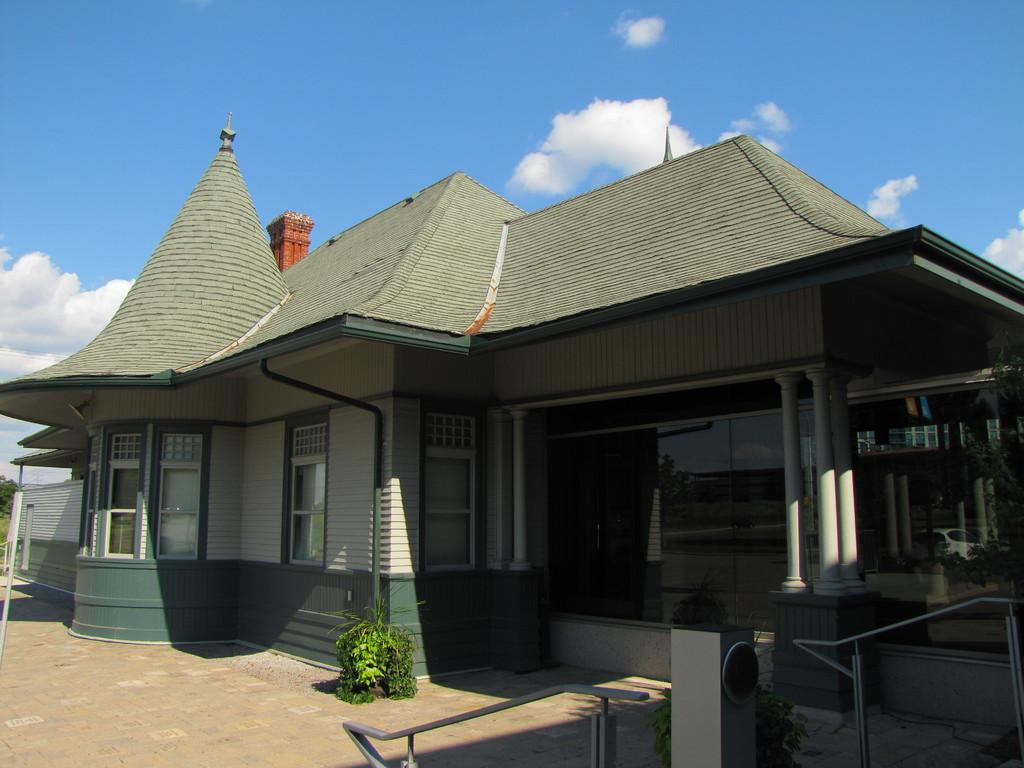What is the main structure visible in the image? There is a building in the image. What is located in front of the building? There is a plant in front of the building. What can be seen in the background of the image? The sky is visible in the background of the image. How many legs can be seen on the fish in the image? There is no fish present in the image, so it is not possible to determine the number of legs on a fish. 